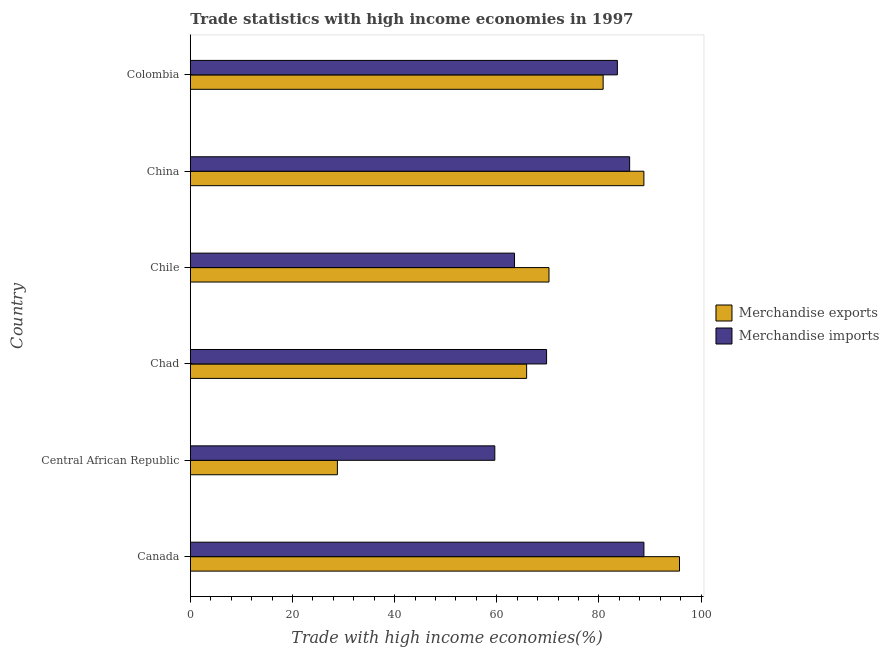How many groups of bars are there?
Offer a terse response. 6. Are the number of bars per tick equal to the number of legend labels?
Provide a short and direct response. Yes. Are the number of bars on each tick of the Y-axis equal?
Make the answer very short. Yes. How many bars are there on the 4th tick from the bottom?
Your answer should be compact. 2. What is the label of the 4th group of bars from the top?
Your answer should be compact. Chad. In how many cases, is the number of bars for a given country not equal to the number of legend labels?
Your answer should be compact. 0. What is the merchandise imports in Colombia?
Your answer should be very brief. 83.6. Across all countries, what is the maximum merchandise imports?
Make the answer very short. 88.8. Across all countries, what is the minimum merchandise exports?
Provide a short and direct response. 28.79. In which country was the merchandise imports minimum?
Give a very brief answer. Central African Republic. What is the total merchandise imports in the graph?
Keep it short and to the point. 451.23. What is the difference between the merchandise imports in Canada and that in Colombia?
Provide a short and direct response. 5.2. What is the difference between the merchandise imports in China and the merchandise exports in Colombia?
Offer a terse response. 5.19. What is the average merchandise imports per country?
Ensure brevity in your answer.  75.2. What is the difference between the merchandise imports and merchandise exports in Chile?
Give a very brief answer. -6.74. What is the ratio of the merchandise imports in Central African Republic to that in Chile?
Offer a very short reply. 0.94. Is the difference between the merchandise exports in China and Colombia greater than the difference between the merchandise imports in China and Colombia?
Keep it short and to the point. Yes. What is the difference between the highest and the second highest merchandise imports?
Your answer should be very brief. 2.8. What is the difference between the highest and the lowest merchandise exports?
Your response must be concise. 66.97. Is the sum of the merchandise exports in Chad and Chile greater than the maximum merchandise imports across all countries?
Your answer should be compact. Yes. How many bars are there?
Your response must be concise. 12. What is the difference between two consecutive major ticks on the X-axis?
Offer a terse response. 20. Are the values on the major ticks of X-axis written in scientific E-notation?
Make the answer very short. No. Does the graph contain any zero values?
Keep it short and to the point. No. Where does the legend appear in the graph?
Give a very brief answer. Center right. What is the title of the graph?
Offer a very short reply. Trade statistics with high income economies in 1997. Does "Long-term debt" appear as one of the legend labels in the graph?
Give a very brief answer. No. What is the label or title of the X-axis?
Offer a terse response. Trade with high income economies(%). What is the Trade with high income economies(%) of Merchandise exports in Canada?
Ensure brevity in your answer.  95.76. What is the Trade with high income economies(%) in Merchandise imports in Canada?
Your answer should be very brief. 88.8. What is the Trade with high income economies(%) of Merchandise exports in Central African Republic?
Offer a very short reply. 28.79. What is the Trade with high income economies(%) of Merchandise imports in Central African Republic?
Keep it short and to the point. 59.61. What is the Trade with high income economies(%) in Merchandise exports in Chad?
Your response must be concise. 65.84. What is the Trade with high income economies(%) of Merchandise imports in Chad?
Give a very brief answer. 69.74. What is the Trade with high income economies(%) in Merchandise exports in Chile?
Provide a succinct answer. 70.21. What is the Trade with high income economies(%) in Merchandise imports in Chile?
Your answer should be very brief. 63.47. What is the Trade with high income economies(%) in Merchandise exports in China?
Offer a very short reply. 88.79. What is the Trade with high income economies(%) in Merchandise imports in China?
Provide a succinct answer. 86. What is the Trade with high income economies(%) in Merchandise exports in Colombia?
Make the answer very short. 80.82. What is the Trade with high income economies(%) in Merchandise imports in Colombia?
Make the answer very short. 83.6. Across all countries, what is the maximum Trade with high income economies(%) of Merchandise exports?
Give a very brief answer. 95.76. Across all countries, what is the maximum Trade with high income economies(%) in Merchandise imports?
Provide a short and direct response. 88.8. Across all countries, what is the minimum Trade with high income economies(%) of Merchandise exports?
Provide a succinct answer. 28.79. Across all countries, what is the minimum Trade with high income economies(%) in Merchandise imports?
Offer a very short reply. 59.61. What is the total Trade with high income economies(%) in Merchandise exports in the graph?
Offer a very short reply. 430.22. What is the total Trade with high income economies(%) of Merchandise imports in the graph?
Offer a very short reply. 451.23. What is the difference between the Trade with high income economies(%) in Merchandise exports in Canada and that in Central African Republic?
Keep it short and to the point. 66.97. What is the difference between the Trade with high income economies(%) in Merchandise imports in Canada and that in Central African Republic?
Offer a terse response. 29.19. What is the difference between the Trade with high income economies(%) of Merchandise exports in Canada and that in Chad?
Give a very brief answer. 29.92. What is the difference between the Trade with high income economies(%) of Merchandise imports in Canada and that in Chad?
Keep it short and to the point. 19.05. What is the difference between the Trade with high income economies(%) in Merchandise exports in Canada and that in Chile?
Offer a very short reply. 25.55. What is the difference between the Trade with high income economies(%) of Merchandise imports in Canada and that in Chile?
Offer a terse response. 25.33. What is the difference between the Trade with high income economies(%) of Merchandise exports in Canada and that in China?
Offer a very short reply. 6.97. What is the difference between the Trade with high income economies(%) of Merchandise imports in Canada and that in China?
Ensure brevity in your answer.  2.8. What is the difference between the Trade with high income economies(%) in Merchandise exports in Canada and that in Colombia?
Offer a very short reply. 14.95. What is the difference between the Trade with high income economies(%) in Merchandise imports in Canada and that in Colombia?
Provide a succinct answer. 5.2. What is the difference between the Trade with high income economies(%) of Merchandise exports in Central African Republic and that in Chad?
Keep it short and to the point. -37.05. What is the difference between the Trade with high income economies(%) of Merchandise imports in Central African Republic and that in Chad?
Your answer should be compact. -10.13. What is the difference between the Trade with high income economies(%) of Merchandise exports in Central African Republic and that in Chile?
Your answer should be very brief. -41.42. What is the difference between the Trade with high income economies(%) in Merchandise imports in Central African Republic and that in Chile?
Provide a short and direct response. -3.86. What is the difference between the Trade with high income economies(%) of Merchandise exports in Central African Republic and that in China?
Offer a very short reply. -60. What is the difference between the Trade with high income economies(%) in Merchandise imports in Central African Republic and that in China?
Your answer should be compact. -26.39. What is the difference between the Trade with high income economies(%) of Merchandise exports in Central African Republic and that in Colombia?
Keep it short and to the point. -52.02. What is the difference between the Trade with high income economies(%) in Merchandise imports in Central African Republic and that in Colombia?
Keep it short and to the point. -23.99. What is the difference between the Trade with high income economies(%) in Merchandise exports in Chad and that in Chile?
Ensure brevity in your answer.  -4.38. What is the difference between the Trade with high income economies(%) in Merchandise imports in Chad and that in Chile?
Provide a succinct answer. 6.27. What is the difference between the Trade with high income economies(%) in Merchandise exports in Chad and that in China?
Your answer should be compact. -22.96. What is the difference between the Trade with high income economies(%) of Merchandise imports in Chad and that in China?
Ensure brevity in your answer.  -16.26. What is the difference between the Trade with high income economies(%) in Merchandise exports in Chad and that in Colombia?
Ensure brevity in your answer.  -14.98. What is the difference between the Trade with high income economies(%) in Merchandise imports in Chad and that in Colombia?
Make the answer very short. -13.86. What is the difference between the Trade with high income economies(%) of Merchandise exports in Chile and that in China?
Provide a succinct answer. -18.58. What is the difference between the Trade with high income economies(%) of Merchandise imports in Chile and that in China?
Provide a succinct answer. -22.53. What is the difference between the Trade with high income economies(%) of Merchandise exports in Chile and that in Colombia?
Keep it short and to the point. -10.6. What is the difference between the Trade with high income economies(%) of Merchandise imports in Chile and that in Colombia?
Give a very brief answer. -20.13. What is the difference between the Trade with high income economies(%) in Merchandise exports in China and that in Colombia?
Provide a short and direct response. 7.98. What is the difference between the Trade with high income economies(%) in Merchandise imports in China and that in Colombia?
Your answer should be compact. 2.4. What is the difference between the Trade with high income economies(%) in Merchandise exports in Canada and the Trade with high income economies(%) in Merchandise imports in Central African Republic?
Your response must be concise. 36.15. What is the difference between the Trade with high income economies(%) of Merchandise exports in Canada and the Trade with high income economies(%) of Merchandise imports in Chad?
Give a very brief answer. 26.02. What is the difference between the Trade with high income economies(%) of Merchandise exports in Canada and the Trade with high income economies(%) of Merchandise imports in Chile?
Your answer should be very brief. 32.29. What is the difference between the Trade with high income economies(%) of Merchandise exports in Canada and the Trade with high income economies(%) of Merchandise imports in China?
Give a very brief answer. 9.76. What is the difference between the Trade with high income economies(%) of Merchandise exports in Canada and the Trade with high income economies(%) of Merchandise imports in Colombia?
Ensure brevity in your answer.  12.16. What is the difference between the Trade with high income economies(%) in Merchandise exports in Central African Republic and the Trade with high income economies(%) in Merchandise imports in Chad?
Provide a succinct answer. -40.95. What is the difference between the Trade with high income economies(%) in Merchandise exports in Central African Republic and the Trade with high income economies(%) in Merchandise imports in Chile?
Keep it short and to the point. -34.68. What is the difference between the Trade with high income economies(%) in Merchandise exports in Central African Republic and the Trade with high income economies(%) in Merchandise imports in China?
Ensure brevity in your answer.  -57.21. What is the difference between the Trade with high income economies(%) in Merchandise exports in Central African Republic and the Trade with high income economies(%) in Merchandise imports in Colombia?
Offer a terse response. -54.81. What is the difference between the Trade with high income economies(%) in Merchandise exports in Chad and the Trade with high income economies(%) in Merchandise imports in Chile?
Offer a terse response. 2.37. What is the difference between the Trade with high income economies(%) of Merchandise exports in Chad and the Trade with high income economies(%) of Merchandise imports in China?
Offer a very short reply. -20.16. What is the difference between the Trade with high income economies(%) in Merchandise exports in Chad and the Trade with high income economies(%) in Merchandise imports in Colombia?
Ensure brevity in your answer.  -17.76. What is the difference between the Trade with high income economies(%) of Merchandise exports in Chile and the Trade with high income economies(%) of Merchandise imports in China?
Ensure brevity in your answer.  -15.79. What is the difference between the Trade with high income economies(%) of Merchandise exports in Chile and the Trade with high income economies(%) of Merchandise imports in Colombia?
Ensure brevity in your answer.  -13.39. What is the difference between the Trade with high income economies(%) of Merchandise exports in China and the Trade with high income economies(%) of Merchandise imports in Colombia?
Your answer should be compact. 5.19. What is the average Trade with high income economies(%) in Merchandise exports per country?
Provide a short and direct response. 71.7. What is the average Trade with high income economies(%) in Merchandise imports per country?
Keep it short and to the point. 75.2. What is the difference between the Trade with high income economies(%) of Merchandise exports and Trade with high income economies(%) of Merchandise imports in Canada?
Give a very brief answer. 6.96. What is the difference between the Trade with high income economies(%) in Merchandise exports and Trade with high income economies(%) in Merchandise imports in Central African Republic?
Your answer should be very brief. -30.82. What is the difference between the Trade with high income economies(%) in Merchandise exports and Trade with high income economies(%) in Merchandise imports in Chad?
Your response must be concise. -3.91. What is the difference between the Trade with high income economies(%) in Merchandise exports and Trade with high income economies(%) in Merchandise imports in Chile?
Ensure brevity in your answer.  6.74. What is the difference between the Trade with high income economies(%) of Merchandise exports and Trade with high income economies(%) of Merchandise imports in China?
Offer a terse response. 2.79. What is the difference between the Trade with high income economies(%) in Merchandise exports and Trade with high income economies(%) in Merchandise imports in Colombia?
Keep it short and to the point. -2.79. What is the ratio of the Trade with high income economies(%) in Merchandise exports in Canada to that in Central African Republic?
Offer a terse response. 3.33. What is the ratio of the Trade with high income economies(%) of Merchandise imports in Canada to that in Central African Republic?
Your response must be concise. 1.49. What is the ratio of the Trade with high income economies(%) of Merchandise exports in Canada to that in Chad?
Give a very brief answer. 1.45. What is the ratio of the Trade with high income economies(%) in Merchandise imports in Canada to that in Chad?
Provide a succinct answer. 1.27. What is the ratio of the Trade with high income economies(%) of Merchandise exports in Canada to that in Chile?
Your response must be concise. 1.36. What is the ratio of the Trade with high income economies(%) in Merchandise imports in Canada to that in Chile?
Ensure brevity in your answer.  1.4. What is the ratio of the Trade with high income economies(%) in Merchandise exports in Canada to that in China?
Offer a very short reply. 1.08. What is the ratio of the Trade with high income economies(%) in Merchandise imports in Canada to that in China?
Offer a very short reply. 1.03. What is the ratio of the Trade with high income economies(%) of Merchandise exports in Canada to that in Colombia?
Provide a short and direct response. 1.19. What is the ratio of the Trade with high income economies(%) of Merchandise imports in Canada to that in Colombia?
Give a very brief answer. 1.06. What is the ratio of the Trade with high income economies(%) in Merchandise exports in Central African Republic to that in Chad?
Your answer should be compact. 0.44. What is the ratio of the Trade with high income economies(%) in Merchandise imports in Central African Republic to that in Chad?
Ensure brevity in your answer.  0.85. What is the ratio of the Trade with high income economies(%) in Merchandise exports in Central African Republic to that in Chile?
Ensure brevity in your answer.  0.41. What is the ratio of the Trade with high income economies(%) of Merchandise imports in Central African Republic to that in Chile?
Provide a succinct answer. 0.94. What is the ratio of the Trade with high income economies(%) of Merchandise exports in Central African Republic to that in China?
Your answer should be very brief. 0.32. What is the ratio of the Trade with high income economies(%) of Merchandise imports in Central African Republic to that in China?
Your response must be concise. 0.69. What is the ratio of the Trade with high income economies(%) in Merchandise exports in Central African Republic to that in Colombia?
Offer a very short reply. 0.36. What is the ratio of the Trade with high income economies(%) of Merchandise imports in Central African Republic to that in Colombia?
Offer a terse response. 0.71. What is the ratio of the Trade with high income economies(%) in Merchandise exports in Chad to that in Chile?
Offer a very short reply. 0.94. What is the ratio of the Trade with high income economies(%) in Merchandise imports in Chad to that in Chile?
Your answer should be compact. 1.1. What is the ratio of the Trade with high income economies(%) in Merchandise exports in Chad to that in China?
Provide a short and direct response. 0.74. What is the ratio of the Trade with high income economies(%) in Merchandise imports in Chad to that in China?
Your answer should be compact. 0.81. What is the ratio of the Trade with high income economies(%) of Merchandise exports in Chad to that in Colombia?
Make the answer very short. 0.81. What is the ratio of the Trade with high income economies(%) of Merchandise imports in Chad to that in Colombia?
Give a very brief answer. 0.83. What is the ratio of the Trade with high income economies(%) in Merchandise exports in Chile to that in China?
Your answer should be very brief. 0.79. What is the ratio of the Trade with high income economies(%) in Merchandise imports in Chile to that in China?
Keep it short and to the point. 0.74. What is the ratio of the Trade with high income economies(%) in Merchandise exports in Chile to that in Colombia?
Provide a succinct answer. 0.87. What is the ratio of the Trade with high income economies(%) in Merchandise imports in Chile to that in Colombia?
Your answer should be compact. 0.76. What is the ratio of the Trade with high income economies(%) of Merchandise exports in China to that in Colombia?
Your answer should be compact. 1.1. What is the ratio of the Trade with high income economies(%) of Merchandise imports in China to that in Colombia?
Ensure brevity in your answer.  1.03. What is the difference between the highest and the second highest Trade with high income economies(%) in Merchandise exports?
Give a very brief answer. 6.97. What is the difference between the highest and the second highest Trade with high income economies(%) of Merchandise imports?
Provide a succinct answer. 2.8. What is the difference between the highest and the lowest Trade with high income economies(%) of Merchandise exports?
Give a very brief answer. 66.97. What is the difference between the highest and the lowest Trade with high income economies(%) in Merchandise imports?
Your answer should be very brief. 29.19. 